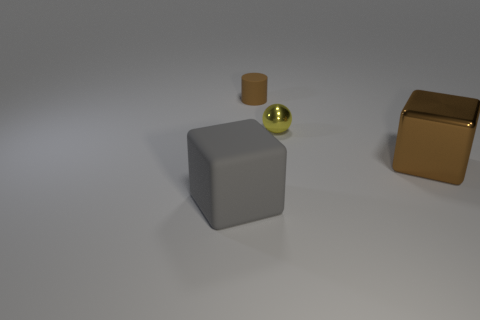Subtract all spheres. How many objects are left? 3 Add 4 large matte cubes. How many objects exist? 8 Add 3 large gray objects. How many large gray objects are left? 4 Add 1 brown balls. How many brown balls exist? 1 Subtract 0 blue cubes. How many objects are left? 4 Subtract all brown cubes. Subtract all brown matte things. How many objects are left? 2 